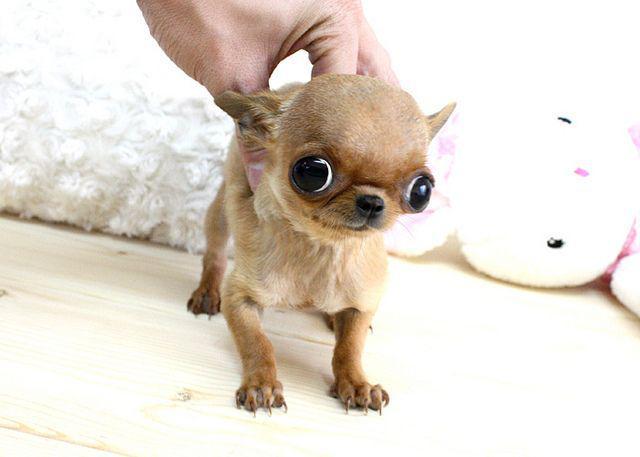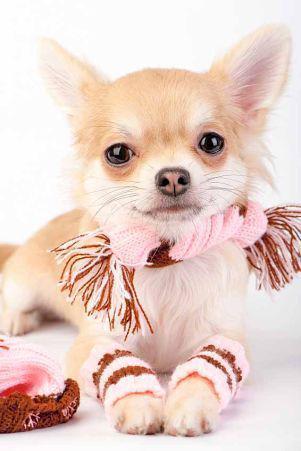The first image is the image on the left, the second image is the image on the right. Considering the images on both sides, is "In the right image, a chihuahua is wearing an object around its neck." valid? Answer yes or no. Yes. The first image is the image on the left, the second image is the image on the right. For the images displayed, is the sentence "Of the two dogs shown, one dog's ears are floppy or folded, and the other dog's ears are pointy and erect." factually correct? Answer yes or no. No. 